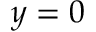<formula> <loc_0><loc_0><loc_500><loc_500>y = 0</formula> 